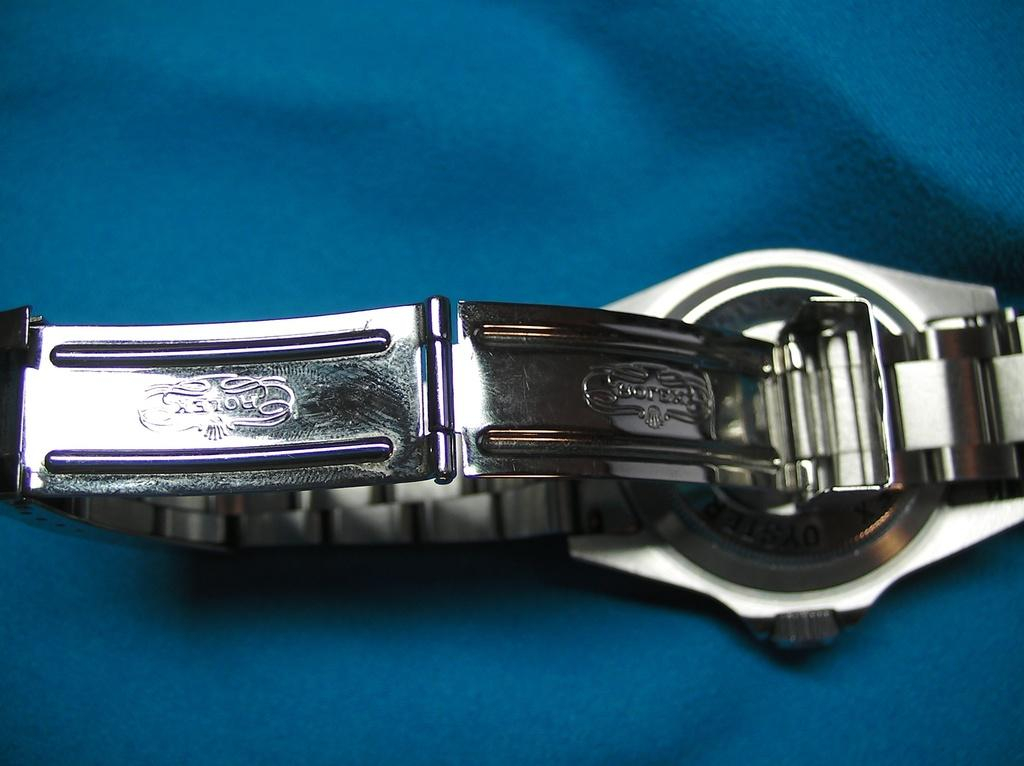<image>
Present a compact description of the photo's key features. The back side of the band of a Rolex wristwatch. 